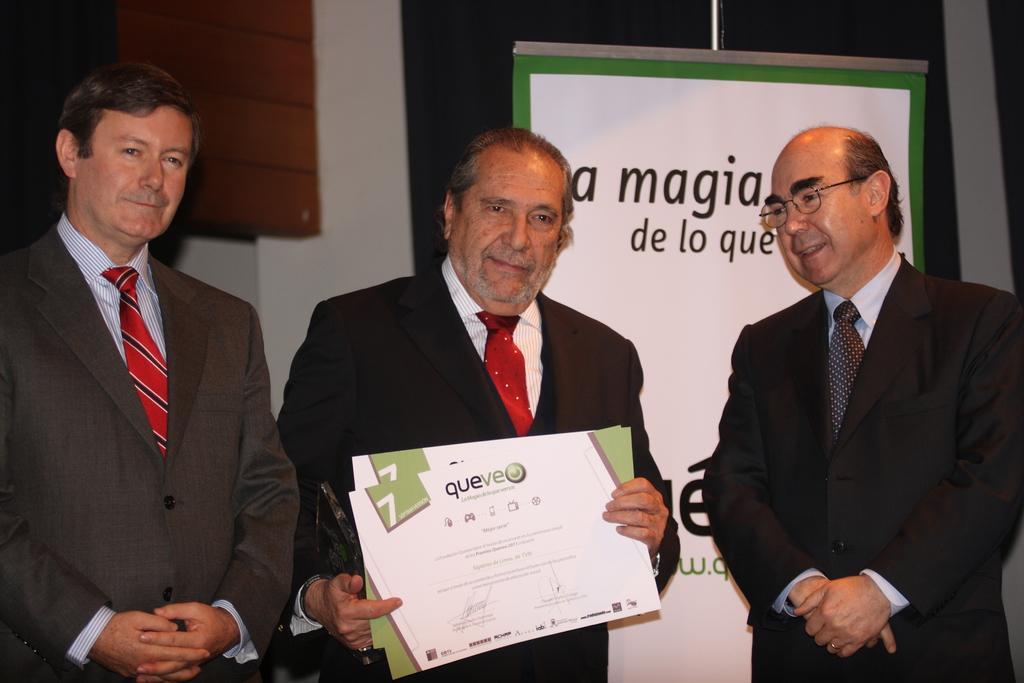How would you summarize this image in a sentence or two? In this image there are three men in the middle who are wearing the suits. The man in the middle is holding the certificates. Behind them there is a banner. Beside the banner there is a wall. 